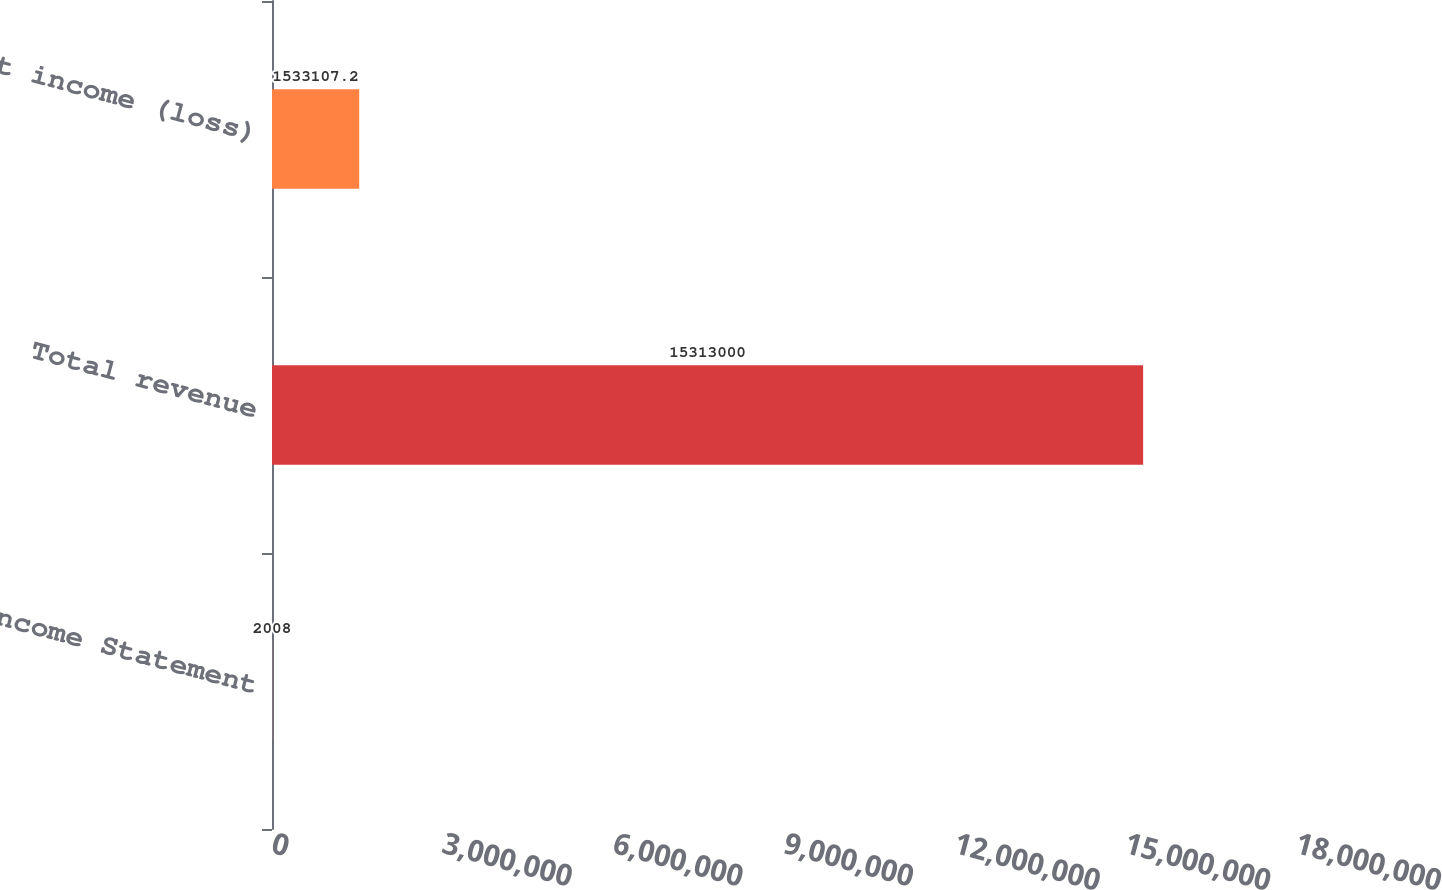Convert chart to OTSL. <chart><loc_0><loc_0><loc_500><loc_500><bar_chart><fcel>Income Statement<fcel>Total revenue<fcel>Net income (loss)<nl><fcel>2008<fcel>1.5313e+07<fcel>1.53311e+06<nl></chart> 